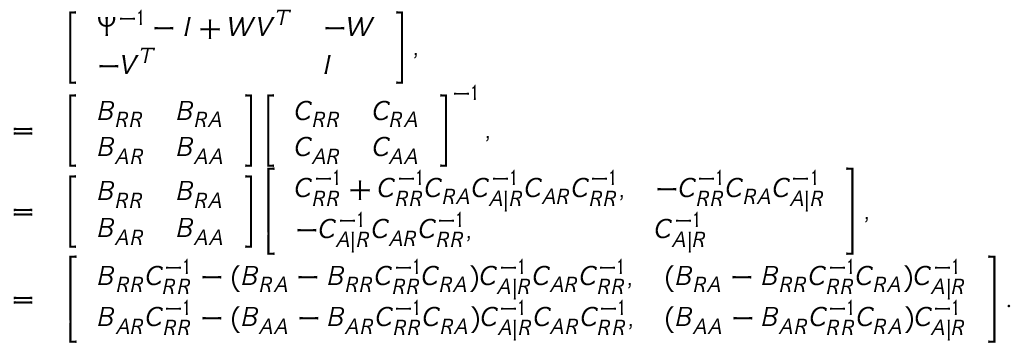Convert formula to latex. <formula><loc_0><loc_0><loc_500><loc_500>\begin{array} { r l } & { \left [ \begin{array} { l l } { \Psi ^ { - 1 } - I + W V ^ { T } } & { - W } \\ { - V ^ { T } } & { I } \end{array} \right ] , } \\ { = } & { \left [ \begin{array} { l l } { B _ { R R } } & { B _ { R A } } \\ { B _ { A R } } & { B _ { A A } } \end{array} \right ] \left [ \begin{array} { l l } { C _ { R R } } & { C _ { R A } } \\ { C _ { A R } } & { C _ { A A } } \end{array} \right ] ^ { - 1 } , } \\ { = } & { \left [ \begin{array} { l l } { B _ { R R } } & { B _ { R A } } \\ { B _ { A R } } & { B _ { A A } } \end{array} \right ] \left [ \begin{array} { l l } { C _ { R R } ^ { - 1 } + C _ { R R } ^ { - 1 } C _ { R A } C _ { A | R } ^ { - 1 } C _ { A R } C _ { R R } ^ { - 1 } , } & { - C _ { R R } ^ { - 1 } C _ { R A } C _ { A | R } ^ { - 1 } } \\ { - C _ { A | R } ^ { - 1 } C _ { A R } C _ { R R } ^ { - 1 } , } & { C _ { A | R } ^ { - 1 } } \end{array} \right ] , } \\ { = } & { \left [ \begin{array} { l l } { B _ { R R } C _ { R R } ^ { - 1 } - ( B _ { R A } - B _ { R R } C _ { R R } ^ { - 1 } C _ { R A } ) C _ { A | R } ^ { - 1 } C _ { A R } C _ { R R } ^ { - 1 } , } & { ( B _ { R A } - B _ { R R } C _ { R R } ^ { - 1 } C _ { R A } ) C _ { A | R } ^ { - 1 } } \\ { B _ { A R } C _ { R R } ^ { - 1 } - ( B _ { A A } - B _ { A R } C _ { R R } ^ { - 1 } C _ { R A } ) C _ { A | R } ^ { - 1 } C _ { A R } C _ { R R } ^ { - 1 } , } & { ( B _ { A A } - B _ { A R } C _ { R R } ^ { - 1 } C _ { R A } ) C _ { A | R } ^ { - 1 } } \end{array} \right ] . } \end{array}</formula> 